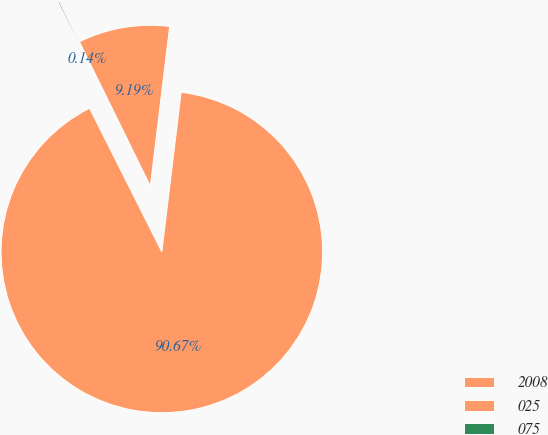Convert chart. <chart><loc_0><loc_0><loc_500><loc_500><pie_chart><fcel>2008<fcel>025<fcel>075<nl><fcel>90.66%<fcel>9.19%<fcel>0.14%<nl></chart> 